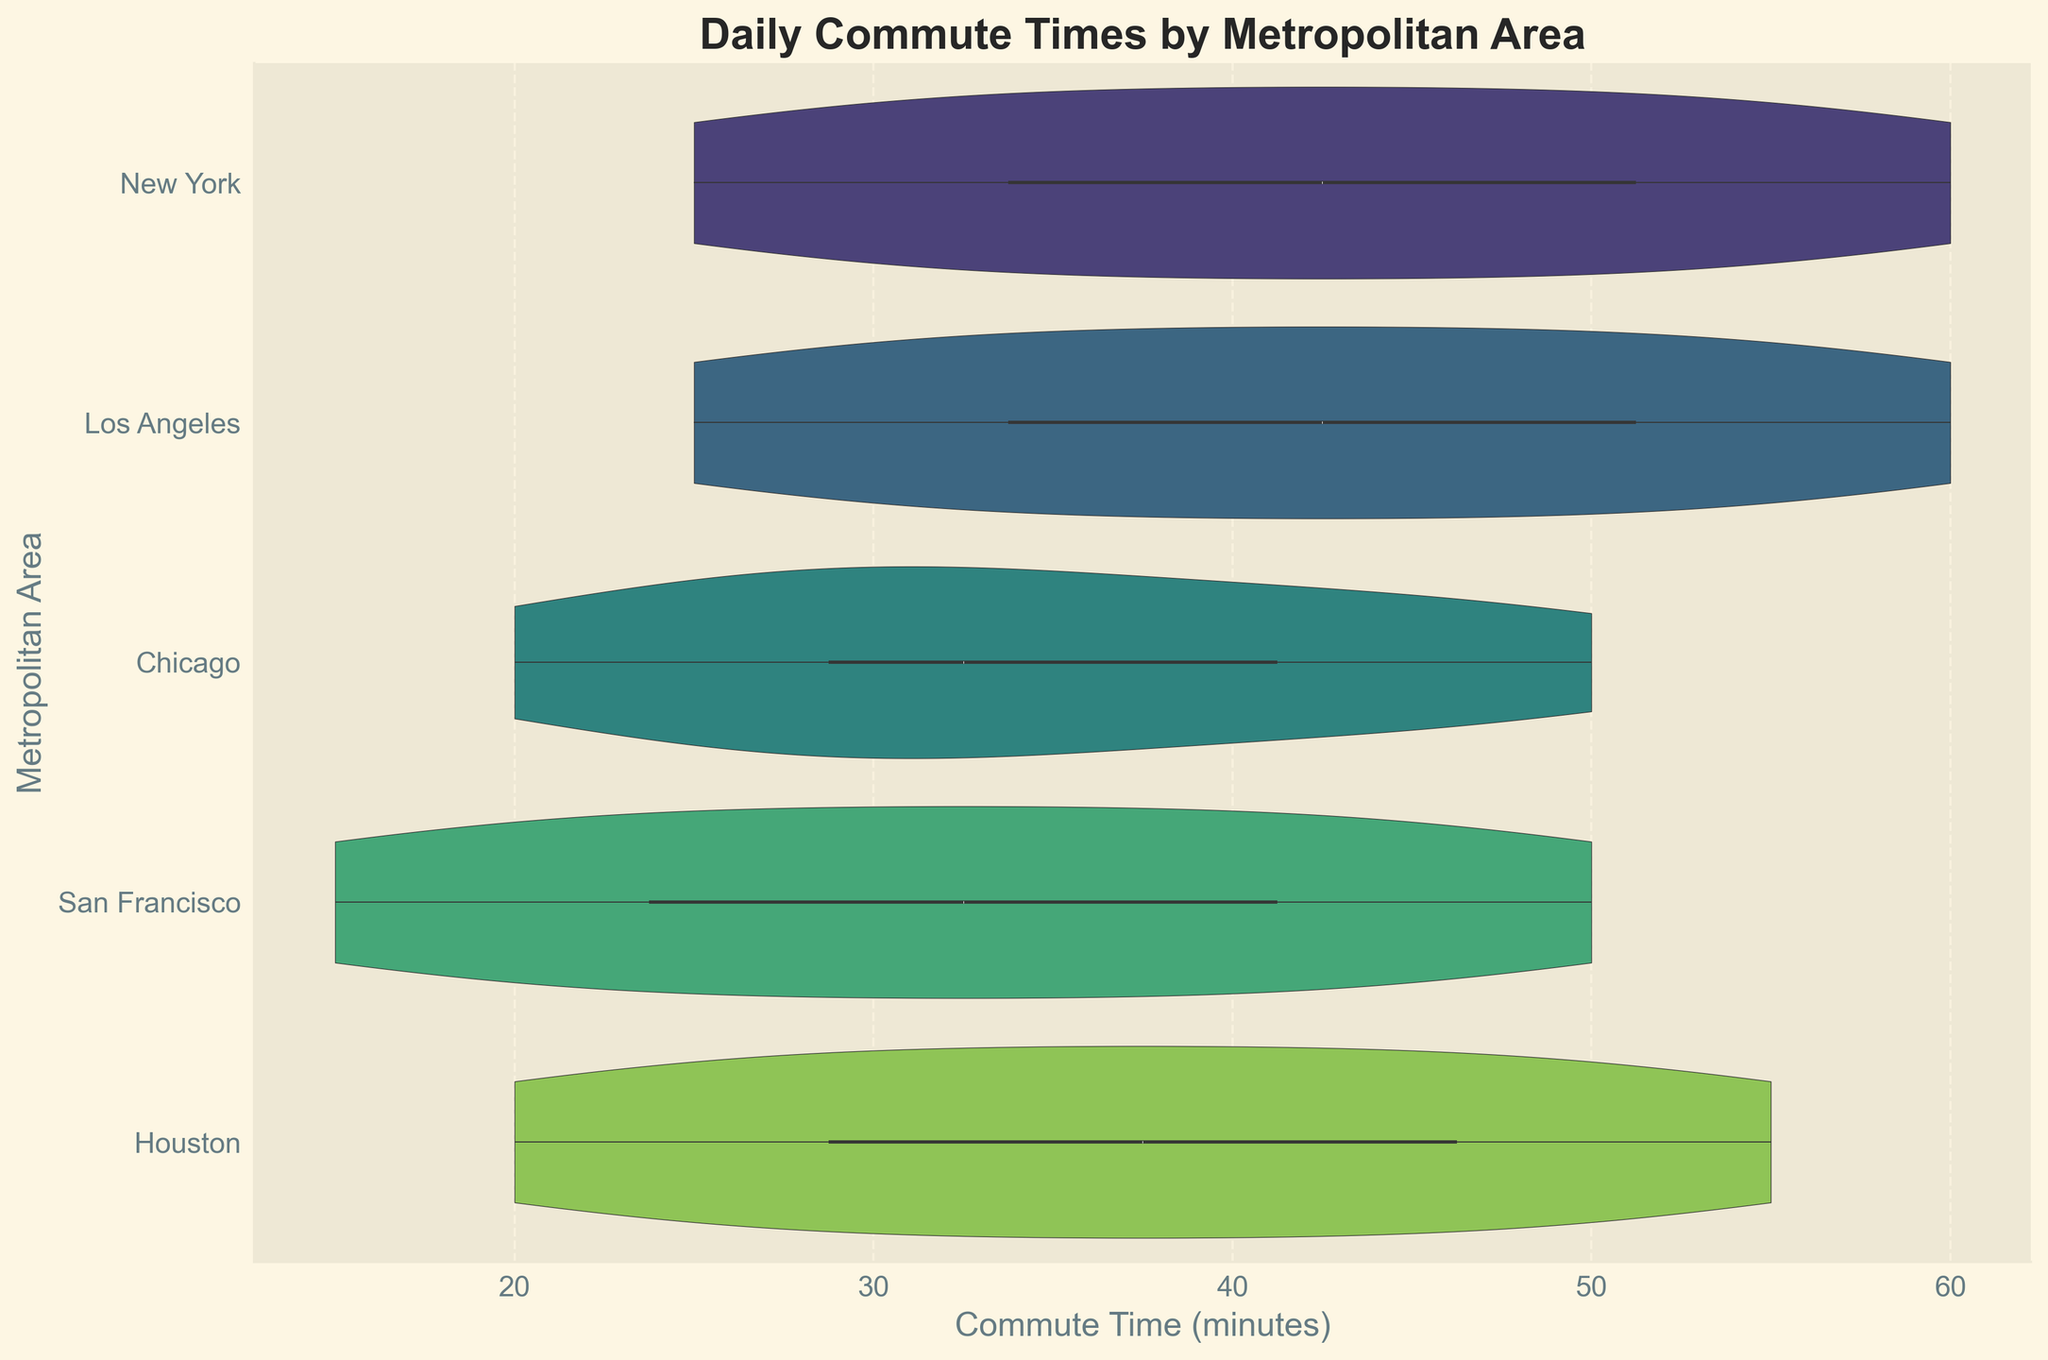What is the title of the figure? The title of the figure is written at the top of the chart.
Answer: Daily Commute Times by Metropolitan Area Which city has the longest commute time range shown in the violin plots? By observing the horizontal length of the violin plots, the city with the largest range of commute times can be determined.
Answer: New York What is the median commute time for Los Angeles? The median commute time is typically shown by a darker line in the middle of the violin plot's box. For Los Angeles, locate this line.
Answer: 40 minutes Which city has the least variability in commute times? The least variability in commute times can be observed from the city with the narrowest violin plot.
Answer: San Francisco Is the average commute time in Houston greater than in Chicago? By comparing the density width and center of the violin plots for Houston and Chicago, estimates of their average commute times can be made.
Answer: No What’s the commute time range for San Francisco? The range can be determined by looking at the ends of the violin plot for San Francisco.
Answer: 15-50 minutes Which city has the highest density of commute times around 30 minutes? The thickness of the violin plot around the 30-minute mark indicates the density of commute times in that range.
Answer: Chicago Are there any cities where the shortest commute time is below 20 minutes? Observing the left ends of all violin plots, check if any city's plot starts before the 20-minute mark.
Answer: Yes How does the spread of commute times in New York compare to that in Houston? Compare the total length of the violin plots of New York and Houston to evaluate the spread.
Answer: New York has a wider spread What can be said about the distribution shape of commute times in Los Angeles? Observe the symmetry and concentration areas within the violin plot for Los Angeles to describe its distribution shape.
Answer: The distribution is fairly symmetric with a concentration around 40-50 minutes 